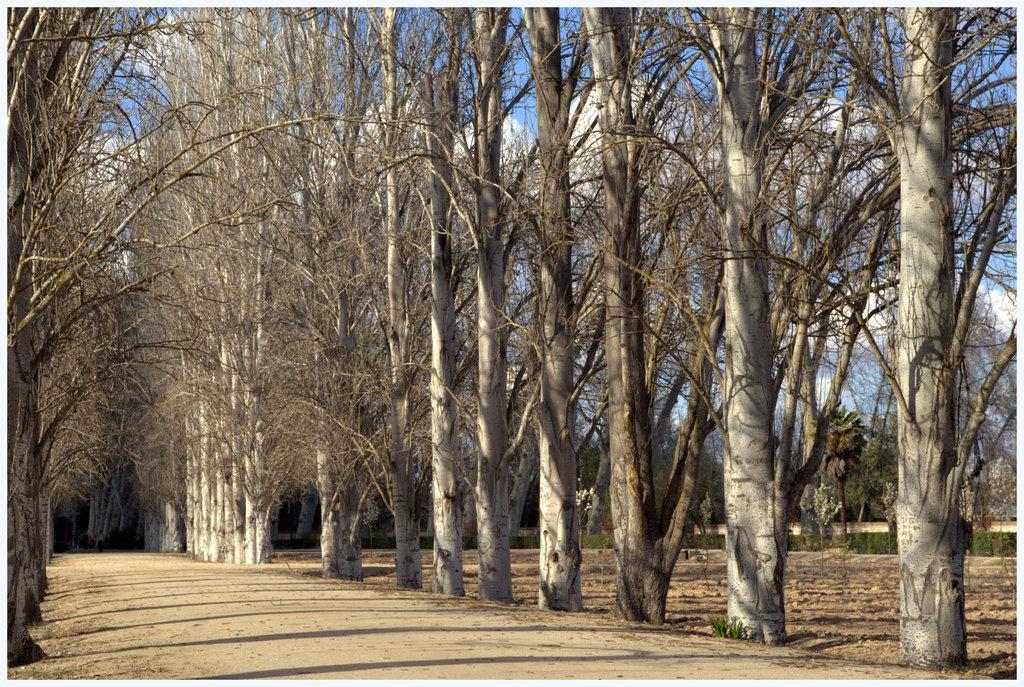How would you summarize this image in a sentence or two? In this image there are group of trees, there are plants on the ground, at the background of the image there is the sky, there are clouds in the sky. 